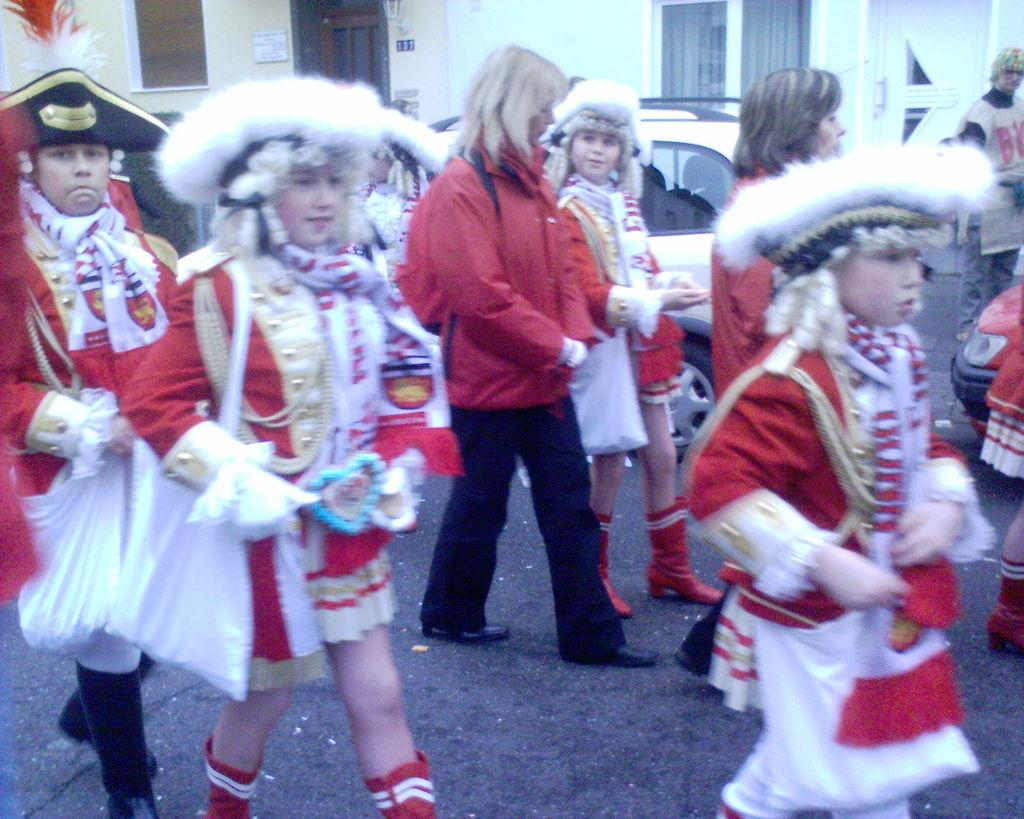What are the people in the image wearing? The people in the image are wearing costumes. What are the people in the image doing? The people are walking. What can be seen in the background of the image? There are vehicles and buildings in the background of the image. What is at the bottom of the image? There is a road at the bottom of the image. What type of cheese is being used to breathe life into the costumes in the image? There is no cheese present in the image, and the costumes do not require breathing life into them. 